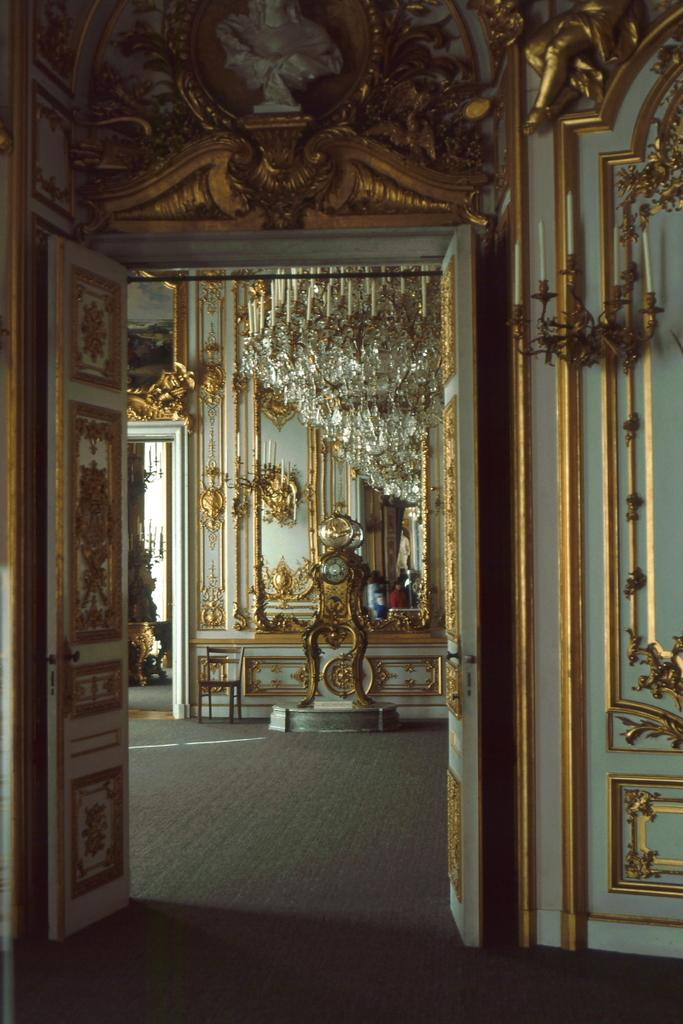What type of door is depicted in the image? There is a designed door in the image. What other architectural elements can be seen in the image? There are walls in the image. What else is present in the image besides the door and walls? There are objects in the image. What can be seen at the bottom of the image? The floor is visible at the bottom portion of the image. What type of pest can be seen crawling on the designed door in the image? There is no pest visible on the designed door in the image. What shape is the window in the image? There is no window present in the image. 